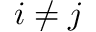Convert formula to latex. <formula><loc_0><loc_0><loc_500><loc_500>i \neq j</formula> 